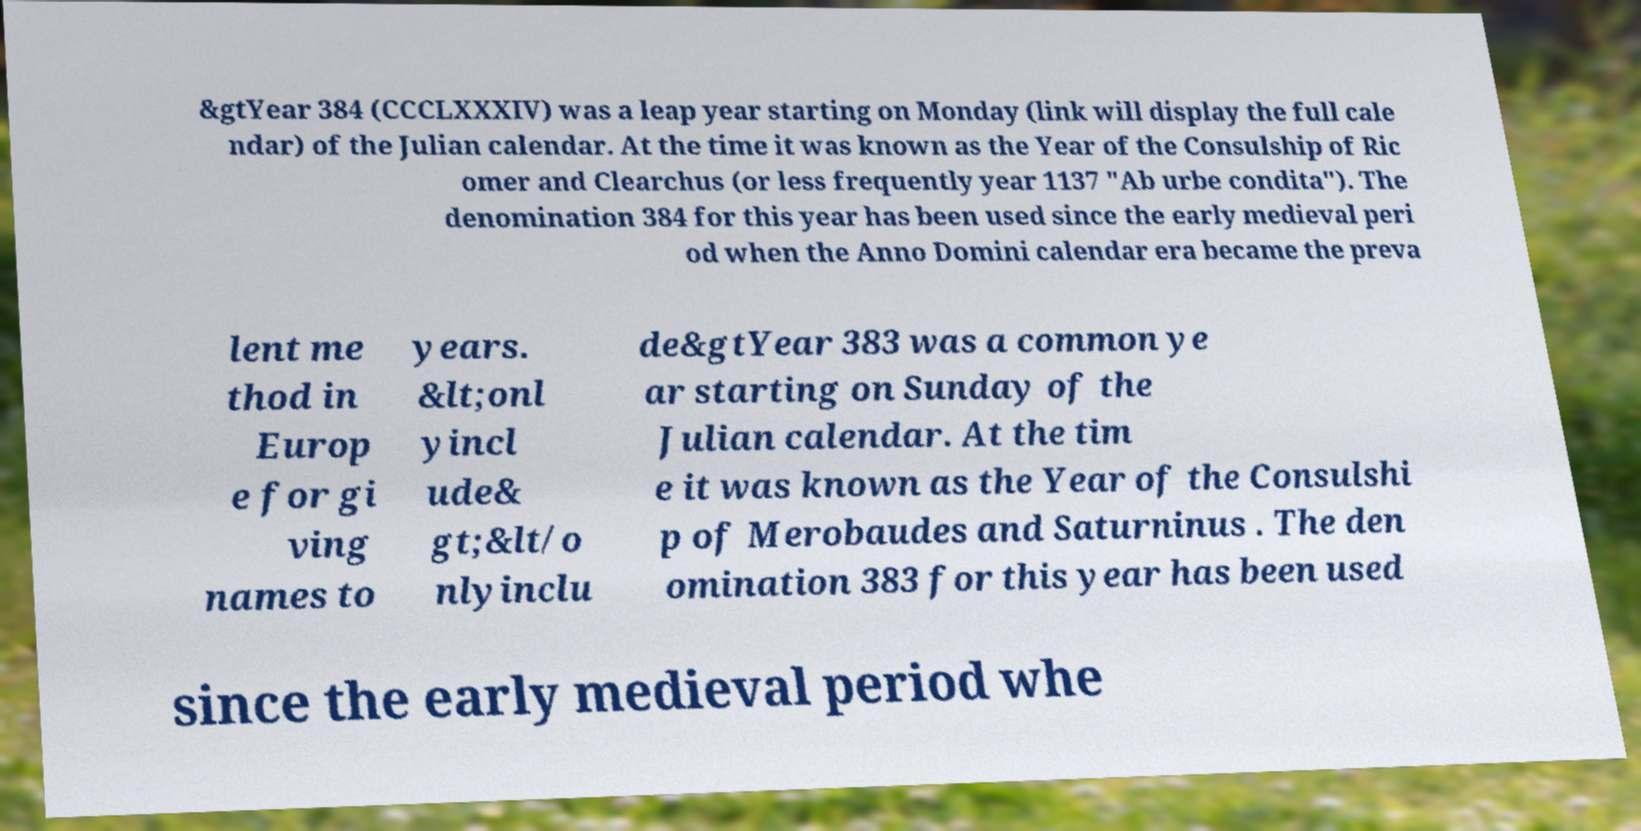For documentation purposes, I need the text within this image transcribed. Could you provide that? &gtYear 384 (CCCLXXXIV) was a leap year starting on Monday (link will display the full cale ndar) of the Julian calendar. At the time it was known as the Year of the Consulship of Ric omer and Clearchus (or less frequently year 1137 "Ab urbe condita"). The denomination 384 for this year has been used since the early medieval peri od when the Anno Domini calendar era became the preva lent me thod in Europ e for gi ving names to years. &lt;onl yincl ude& gt;&lt/o nlyinclu de&gtYear 383 was a common ye ar starting on Sunday of the Julian calendar. At the tim e it was known as the Year of the Consulshi p of Merobaudes and Saturninus . The den omination 383 for this year has been used since the early medieval period whe 